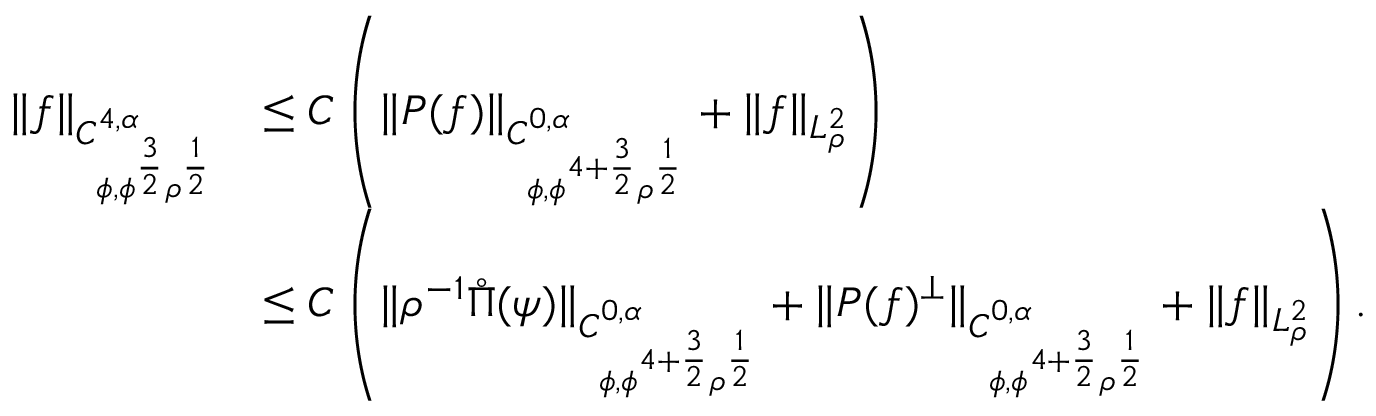Convert formula to latex. <formula><loc_0><loc_0><loc_500><loc_500>\begin{array} { r l } { \| f \| _ { C _ { \phi , \phi ^ { \frac { 3 } { 2 } } \rho ^ { \frac { 1 } { 2 } } } ^ { 4 , \alpha } } } & { \leq C \left ( \| P ( f ) \| _ { C _ { \phi , \phi ^ { 4 + \frac { 3 } { 2 } } \rho ^ { \frac { 1 } { 2 } } } ^ { 0 , \alpha } } + \| f \| _ { L _ { \rho } ^ { 2 } } \right ) } \\ & { \leq C \left ( \| \rho ^ { - 1 } \mathring { \Pi } ( \psi ) \| _ { C _ { \phi , \phi ^ { 4 + \frac { 3 } { 2 } } \rho ^ { \frac { 1 } { 2 } } } ^ { 0 , \alpha } } + \| P ( f ) ^ { \perp } \| _ { C _ { \phi , \phi ^ { 4 + \frac { 3 } { 2 } } \rho ^ { \frac { 1 } { 2 } } } ^ { 0 , \alpha } } + \| f \| _ { L _ { \rho } ^ { 2 } } \right ) . } \end{array}</formula> 